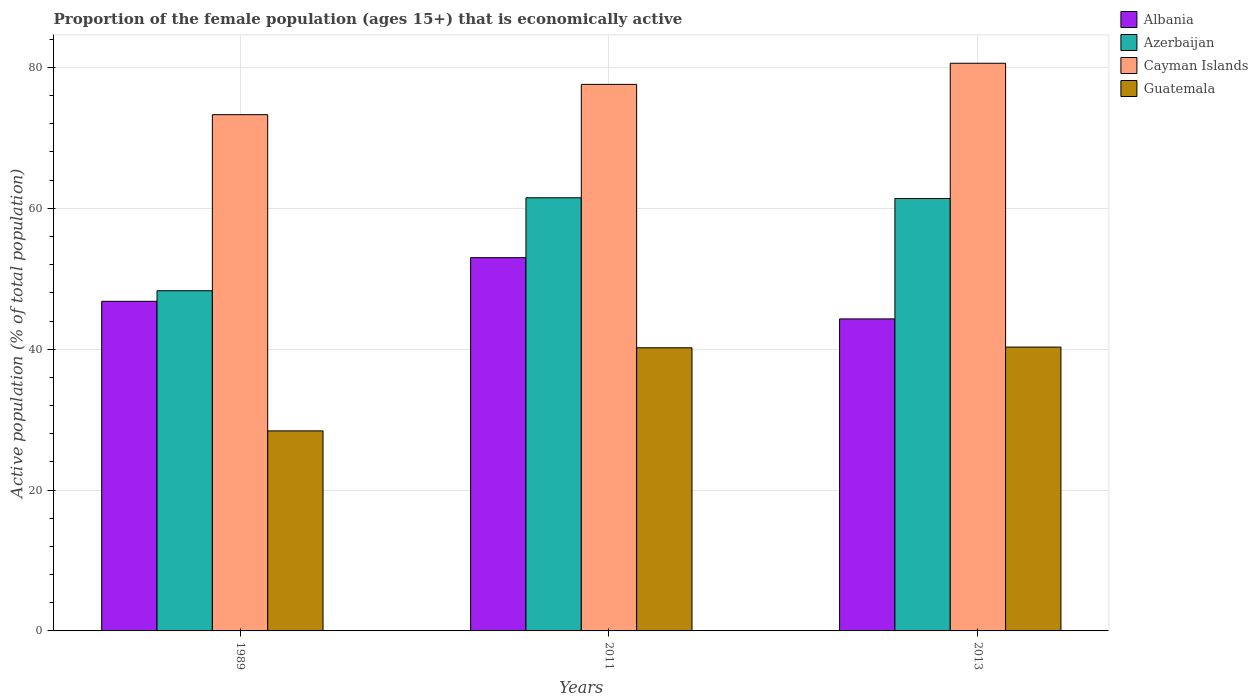How many groups of bars are there?
Make the answer very short. 3. How many bars are there on the 2nd tick from the right?
Give a very brief answer. 4. In how many cases, is the number of bars for a given year not equal to the number of legend labels?
Provide a short and direct response. 0. What is the proportion of the female population that is economically active in Cayman Islands in 2013?
Provide a short and direct response. 80.6. Across all years, what is the maximum proportion of the female population that is economically active in Albania?
Your answer should be very brief. 53. Across all years, what is the minimum proportion of the female population that is economically active in Azerbaijan?
Give a very brief answer. 48.3. In which year was the proportion of the female population that is economically active in Guatemala maximum?
Your answer should be very brief. 2013. What is the total proportion of the female population that is economically active in Guatemala in the graph?
Ensure brevity in your answer.  108.9. What is the difference between the proportion of the female population that is economically active in Cayman Islands in 1989 and that in 2011?
Make the answer very short. -4.3. What is the difference between the proportion of the female population that is economically active in Albania in 2011 and the proportion of the female population that is economically active in Guatemala in 2013?
Give a very brief answer. 12.7. What is the average proportion of the female population that is economically active in Guatemala per year?
Make the answer very short. 36.3. In the year 1989, what is the difference between the proportion of the female population that is economically active in Guatemala and proportion of the female population that is economically active in Albania?
Keep it short and to the point. -18.4. In how many years, is the proportion of the female population that is economically active in Guatemala greater than 16 %?
Offer a terse response. 3. What is the ratio of the proportion of the female population that is economically active in Guatemala in 1989 to that in 2013?
Your response must be concise. 0.7. Is the proportion of the female population that is economically active in Azerbaijan in 2011 less than that in 2013?
Offer a very short reply. No. What is the difference between the highest and the second highest proportion of the female population that is economically active in Azerbaijan?
Ensure brevity in your answer.  0.1. What is the difference between the highest and the lowest proportion of the female population that is economically active in Albania?
Provide a succinct answer. 8.7. In how many years, is the proportion of the female population that is economically active in Azerbaijan greater than the average proportion of the female population that is economically active in Azerbaijan taken over all years?
Keep it short and to the point. 2. Is the sum of the proportion of the female population that is economically active in Azerbaijan in 2011 and 2013 greater than the maximum proportion of the female population that is economically active in Cayman Islands across all years?
Your answer should be compact. Yes. What does the 1st bar from the left in 2011 represents?
Make the answer very short. Albania. What does the 3rd bar from the right in 1989 represents?
Ensure brevity in your answer.  Azerbaijan. How many years are there in the graph?
Your answer should be very brief. 3. Are the values on the major ticks of Y-axis written in scientific E-notation?
Your answer should be very brief. No. Does the graph contain any zero values?
Offer a very short reply. No. Does the graph contain grids?
Provide a short and direct response. Yes. What is the title of the graph?
Give a very brief answer. Proportion of the female population (ages 15+) that is economically active. What is the label or title of the Y-axis?
Keep it short and to the point. Active population (% of total population). What is the Active population (% of total population) of Albania in 1989?
Keep it short and to the point. 46.8. What is the Active population (% of total population) in Azerbaijan in 1989?
Keep it short and to the point. 48.3. What is the Active population (% of total population) of Cayman Islands in 1989?
Your answer should be very brief. 73.3. What is the Active population (% of total population) in Guatemala in 1989?
Keep it short and to the point. 28.4. What is the Active population (% of total population) in Azerbaijan in 2011?
Provide a short and direct response. 61.5. What is the Active population (% of total population) of Cayman Islands in 2011?
Provide a short and direct response. 77.6. What is the Active population (% of total population) of Guatemala in 2011?
Your answer should be compact. 40.2. What is the Active population (% of total population) in Albania in 2013?
Your answer should be compact. 44.3. What is the Active population (% of total population) of Azerbaijan in 2013?
Offer a terse response. 61.4. What is the Active population (% of total population) in Cayman Islands in 2013?
Provide a short and direct response. 80.6. What is the Active population (% of total population) of Guatemala in 2013?
Provide a succinct answer. 40.3. Across all years, what is the maximum Active population (% of total population) in Azerbaijan?
Ensure brevity in your answer.  61.5. Across all years, what is the maximum Active population (% of total population) of Cayman Islands?
Ensure brevity in your answer.  80.6. Across all years, what is the maximum Active population (% of total population) in Guatemala?
Give a very brief answer. 40.3. Across all years, what is the minimum Active population (% of total population) of Albania?
Your response must be concise. 44.3. Across all years, what is the minimum Active population (% of total population) of Azerbaijan?
Provide a short and direct response. 48.3. Across all years, what is the minimum Active population (% of total population) in Cayman Islands?
Provide a short and direct response. 73.3. Across all years, what is the minimum Active population (% of total population) in Guatemala?
Make the answer very short. 28.4. What is the total Active population (% of total population) in Albania in the graph?
Offer a terse response. 144.1. What is the total Active population (% of total population) in Azerbaijan in the graph?
Ensure brevity in your answer.  171.2. What is the total Active population (% of total population) in Cayman Islands in the graph?
Provide a short and direct response. 231.5. What is the total Active population (% of total population) of Guatemala in the graph?
Ensure brevity in your answer.  108.9. What is the difference between the Active population (% of total population) in Albania in 1989 and that in 2011?
Your answer should be very brief. -6.2. What is the difference between the Active population (% of total population) of Cayman Islands in 1989 and that in 2011?
Keep it short and to the point. -4.3. What is the difference between the Active population (% of total population) in Albania in 1989 and that in 2013?
Keep it short and to the point. 2.5. What is the difference between the Active population (% of total population) in Guatemala in 1989 and that in 2013?
Provide a succinct answer. -11.9. What is the difference between the Active population (% of total population) in Albania in 2011 and that in 2013?
Provide a succinct answer. 8.7. What is the difference between the Active population (% of total population) of Azerbaijan in 2011 and that in 2013?
Provide a succinct answer. 0.1. What is the difference between the Active population (% of total population) in Cayman Islands in 2011 and that in 2013?
Give a very brief answer. -3. What is the difference between the Active population (% of total population) of Albania in 1989 and the Active population (% of total population) of Azerbaijan in 2011?
Offer a terse response. -14.7. What is the difference between the Active population (% of total population) in Albania in 1989 and the Active population (% of total population) in Cayman Islands in 2011?
Give a very brief answer. -30.8. What is the difference between the Active population (% of total population) in Albania in 1989 and the Active population (% of total population) in Guatemala in 2011?
Your answer should be very brief. 6.6. What is the difference between the Active population (% of total population) of Azerbaijan in 1989 and the Active population (% of total population) of Cayman Islands in 2011?
Give a very brief answer. -29.3. What is the difference between the Active population (% of total population) in Cayman Islands in 1989 and the Active population (% of total population) in Guatemala in 2011?
Provide a short and direct response. 33.1. What is the difference between the Active population (% of total population) of Albania in 1989 and the Active population (% of total population) of Azerbaijan in 2013?
Ensure brevity in your answer.  -14.6. What is the difference between the Active population (% of total population) of Albania in 1989 and the Active population (% of total population) of Cayman Islands in 2013?
Your answer should be compact. -33.8. What is the difference between the Active population (% of total population) in Azerbaijan in 1989 and the Active population (% of total population) in Cayman Islands in 2013?
Keep it short and to the point. -32.3. What is the difference between the Active population (% of total population) in Azerbaijan in 1989 and the Active population (% of total population) in Guatemala in 2013?
Ensure brevity in your answer.  8. What is the difference between the Active population (% of total population) of Cayman Islands in 1989 and the Active population (% of total population) of Guatemala in 2013?
Your answer should be compact. 33. What is the difference between the Active population (% of total population) in Albania in 2011 and the Active population (% of total population) in Azerbaijan in 2013?
Offer a terse response. -8.4. What is the difference between the Active population (% of total population) of Albania in 2011 and the Active population (% of total population) of Cayman Islands in 2013?
Provide a succinct answer. -27.6. What is the difference between the Active population (% of total population) of Albania in 2011 and the Active population (% of total population) of Guatemala in 2013?
Provide a succinct answer. 12.7. What is the difference between the Active population (% of total population) in Azerbaijan in 2011 and the Active population (% of total population) in Cayman Islands in 2013?
Your response must be concise. -19.1. What is the difference between the Active population (% of total population) in Azerbaijan in 2011 and the Active population (% of total population) in Guatemala in 2013?
Your response must be concise. 21.2. What is the difference between the Active population (% of total population) in Cayman Islands in 2011 and the Active population (% of total population) in Guatemala in 2013?
Ensure brevity in your answer.  37.3. What is the average Active population (% of total population) of Albania per year?
Offer a very short reply. 48.03. What is the average Active population (% of total population) in Azerbaijan per year?
Offer a terse response. 57.07. What is the average Active population (% of total population) of Cayman Islands per year?
Your response must be concise. 77.17. What is the average Active population (% of total population) in Guatemala per year?
Ensure brevity in your answer.  36.3. In the year 1989, what is the difference between the Active population (% of total population) in Albania and Active population (% of total population) in Cayman Islands?
Ensure brevity in your answer.  -26.5. In the year 1989, what is the difference between the Active population (% of total population) in Albania and Active population (% of total population) in Guatemala?
Give a very brief answer. 18.4. In the year 1989, what is the difference between the Active population (% of total population) in Cayman Islands and Active population (% of total population) in Guatemala?
Your response must be concise. 44.9. In the year 2011, what is the difference between the Active population (% of total population) of Albania and Active population (% of total population) of Cayman Islands?
Your answer should be very brief. -24.6. In the year 2011, what is the difference between the Active population (% of total population) in Albania and Active population (% of total population) in Guatemala?
Give a very brief answer. 12.8. In the year 2011, what is the difference between the Active population (% of total population) of Azerbaijan and Active population (% of total population) of Cayman Islands?
Give a very brief answer. -16.1. In the year 2011, what is the difference between the Active population (% of total population) of Azerbaijan and Active population (% of total population) of Guatemala?
Keep it short and to the point. 21.3. In the year 2011, what is the difference between the Active population (% of total population) of Cayman Islands and Active population (% of total population) of Guatemala?
Keep it short and to the point. 37.4. In the year 2013, what is the difference between the Active population (% of total population) of Albania and Active population (% of total population) of Azerbaijan?
Your response must be concise. -17.1. In the year 2013, what is the difference between the Active population (% of total population) in Albania and Active population (% of total population) in Cayman Islands?
Your answer should be very brief. -36.3. In the year 2013, what is the difference between the Active population (% of total population) of Azerbaijan and Active population (% of total population) of Cayman Islands?
Offer a very short reply. -19.2. In the year 2013, what is the difference between the Active population (% of total population) in Azerbaijan and Active population (% of total population) in Guatemala?
Offer a very short reply. 21.1. In the year 2013, what is the difference between the Active population (% of total population) in Cayman Islands and Active population (% of total population) in Guatemala?
Ensure brevity in your answer.  40.3. What is the ratio of the Active population (% of total population) in Albania in 1989 to that in 2011?
Provide a short and direct response. 0.88. What is the ratio of the Active population (% of total population) in Azerbaijan in 1989 to that in 2011?
Offer a terse response. 0.79. What is the ratio of the Active population (% of total population) of Cayman Islands in 1989 to that in 2011?
Offer a terse response. 0.94. What is the ratio of the Active population (% of total population) in Guatemala in 1989 to that in 2011?
Offer a very short reply. 0.71. What is the ratio of the Active population (% of total population) of Albania in 1989 to that in 2013?
Ensure brevity in your answer.  1.06. What is the ratio of the Active population (% of total population) in Azerbaijan in 1989 to that in 2013?
Your response must be concise. 0.79. What is the ratio of the Active population (% of total population) in Cayman Islands in 1989 to that in 2013?
Keep it short and to the point. 0.91. What is the ratio of the Active population (% of total population) in Guatemala in 1989 to that in 2013?
Keep it short and to the point. 0.7. What is the ratio of the Active population (% of total population) in Albania in 2011 to that in 2013?
Make the answer very short. 1.2. What is the ratio of the Active population (% of total population) of Cayman Islands in 2011 to that in 2013?
Offer a terse response. 0.96. What is the difference between the highest and the second highest Active population (% of total population) in Albania?
Your answer should be very brief. 6.2. What is the difference between the highest and the second highest Active population (% of total population) of Cayman Islands?
Offer a very short reply. 3. What is the difference between the highest and the second highest Active population (% of total population) of Guatemala?
Make the answer very short. 0.1. 